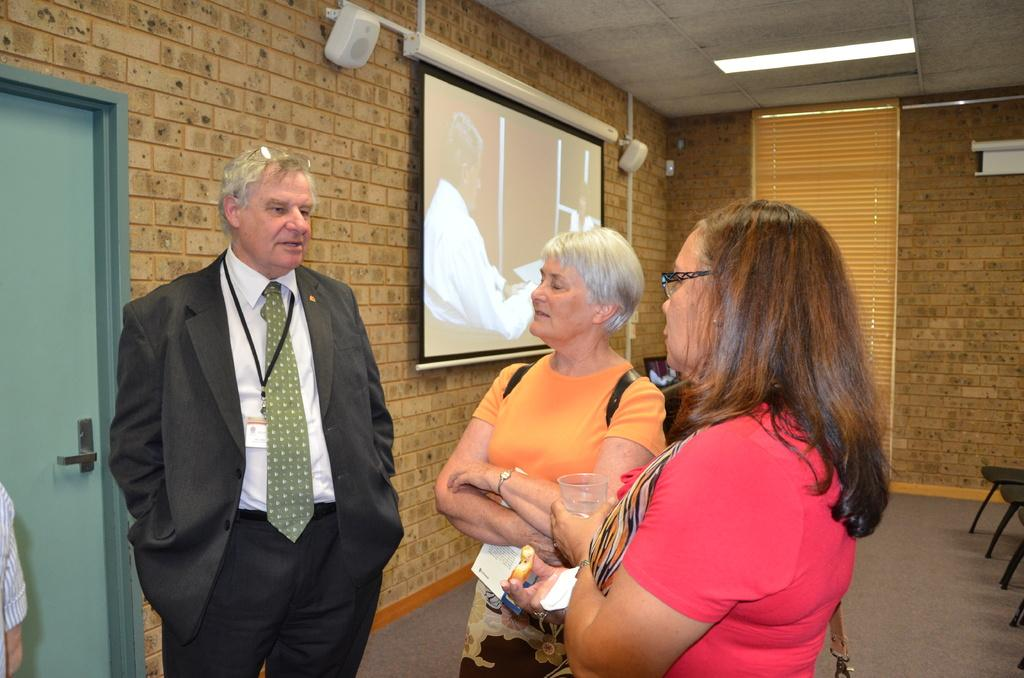What device is visible in the image? There is a projector in the image. Who or what can be seen in the image besides the projector? There are people and cars in the image. What architectural feature is present in the image? There is a door in the image. What appliance is visible in the image? There is an air conditioner in the image. What type of infrastructure is present in the image? There are pipes in the image. What color is the ink used by the woman in the image? There is no woman present in the image, and therefore no ink or color can be associated with her. What type of animal is the cub in the image? There is no cub present in the image. 